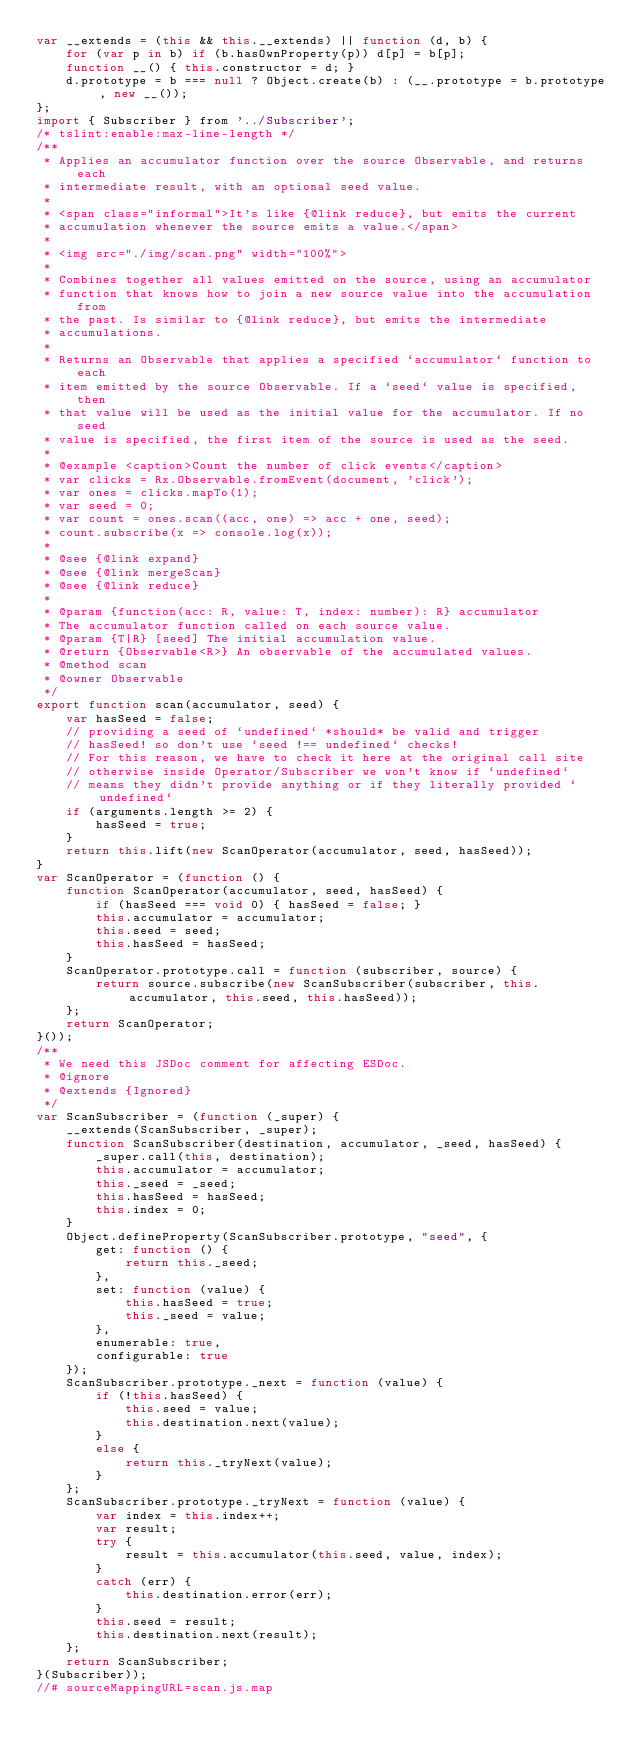<code> <loc_0><loc_0><loc_500><loc_500><_JavaScript_>var __extends = (this && this.__extends) || function (d, b) {
    for (var p in b) if (b.hasOwnProperty(p)) d[p] = b[p];
    function __() { this.constructor = d; }
    d.prototype = b === null ? Object.create(b) : (__.prototype = b.prototype, new __());
};
import { Subscriber } from '../Subscriber';
/* tslint:enable:max-line-length */
/**
 * Applies an accumulator function over the source Observable, and returns each
 * intermediate result, with an optional seed value.
 *
 * <span class="informal">It's like {@link reduce}, but emits the current
 * accumulation whenever the source emits a value.</span>
 *
 * <img src="./img/scan.png" width="100%">
 *
 * Combines together all values emitted on the source, using an accumulator
 * function that knows how to join a new source value into the accumulation from
 * the past. Is similar to {@link reduce}, but emits the intermediate
 * accumulations.
 *
 * Returns an Observable that applies a specified `accumulator` function to each
 * item emitted by the source Observable. If a `seed` value is specified, then
 * that value will be used as the initial value for the accumulator. If no seed
 * value is specified, the first item of the source is used as the seed.
 *
 * @example <caption>Count the number of click events</caption>
 * var clicks = Rx.Observable.fromEvent(document, 'click');
 * var ones = clicks.mapTo(1);
 * var seed = 0;
 * var count = ones.scan((acc, one) => acc + one, seed);
 * count.subscribe(x => console.log(x));
 *
 * @see {@link expand}
 * @see {@link mergeScan}
 * @see {@link reduce}
 *
 * @param {function(acc: R, value: T, index: number): R} accumulator
 * The accumulator function called on each source value.
 * @param {T|R} [seed] The initial accumulation value.
 * @return {Observable<R>} An observable of the accumulated values.
 * @method scan
 * @owner Observable
 */
export function scan(accumulator, seed) {
    var hasSeed = false;
    // providing a seed of `undefined` *should* be valid and trigger
    // hasSeed! so don't use `seed !== undefined` checks!
    // For this reason, we have to check it here at the original call site
    // otherwise inside Operator/Subscriber we won't know if `undefined`
    // means they didn't provide anything or if they literally provided `undefined`
    if (arguments.length >= 2) {
        hasSeed = true;
    }
    return this.lift(new ScanOperator(accumulator, seed, hasSeed));
}
var ScanOperator = (function () {
    function ScanOperator(accumulator, seed, hasSeed) {
        if (hasSeed === void 0) { hasSeed = false; }
        this.accumulator = accumulator;
        this.seed = seed;
        this.hasSeed = hasSeed;
    }
    ScanOperator.prototype.call = function (subscriber, source) {
        return source.subscribe(new ScanSubscriber(subscriber, this.accumulator, this.seed, this.hasSeed));
    };
    return ScanOperator;
}());
/**
 * We need this JSDoc comment for affecting ESDoc.
 * @ignore
 * @extends {Ignored}
 */
var ScanSubscriber = (function (_super) {
    __extends(ScanSubscriber, _super);
    function ScanSubscriber(destination, accumulator, _seed, hasSeed) {
        _super.call(this, destination);
        this.accumulator = accumulator;
        this._seed = _seed;
        this.hasSeed = hasSeed;
        this.index = 0;
    }
    Object.defineProperty(ScanSubscriber.prototype, "seed", {
        get: function () {
            return this._seed;
        },
        set: function (value) {
            this.hasSeed = true;
            this._seed = value;
        },
        enumerable: true,
        configurable: true
    });
    ScanSubscriber.prototype._next = function (value) {
        if (!this.hasSeed) {
            this.seed = value;
            this.destination.next(value);
        }
        else {
            return this._tryNext(value);
        }
    };
    ScanSubscriber.prototype._tryNext = function (value) {
        var index = this.index++;
        var result;
        try {
            result = this.accumulator(this.seed, value, index);
        }
        catch (err) {
            this.destination.error(err);
        }
        this.seed = result;
        this.destination.next(result);
    };
    return ScanSubscriber;
}(Subscriber));
//# sourceMappingURL=scan.js.map</code> 